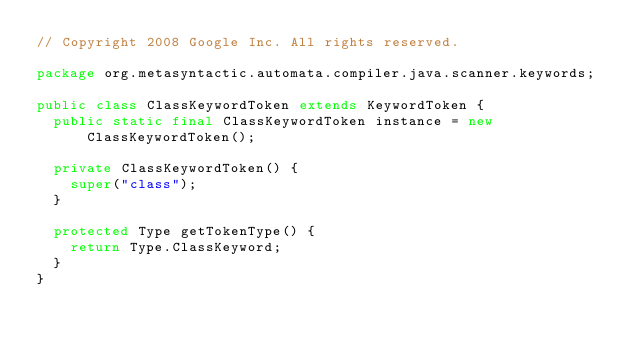Convert code to text. <code><loc_0><loc_0><loc_500><loc_500><_Java_>// Copyright 2008 Google Inc. All rights reserved.

package org.metasyntactic.automata.compiler.java.scanner.keywords;

public class ClassKeywordToken extends KeywordToken {
  public static final ClassKeywordToken instance = new ClassKeywordToken();

  private ClassKeywordToken() {
    super("class");
  }

  protected Type getTokenType() {
    return Type.ClassKeyword;
  }
}
</code> 